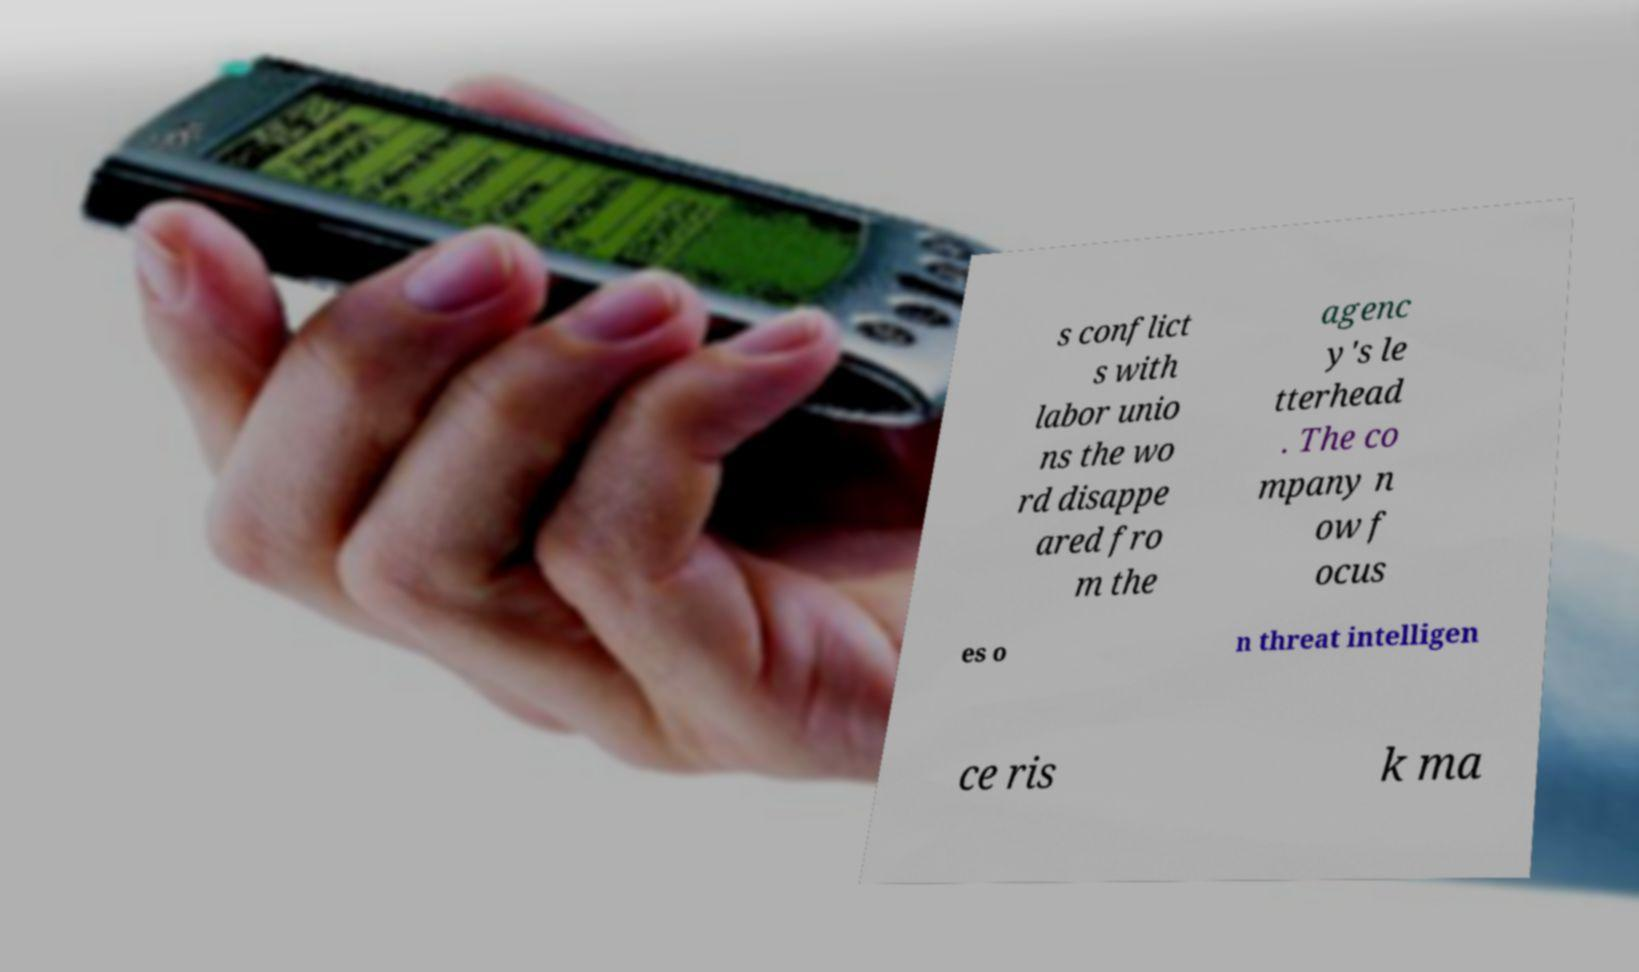For documentation purposes, I need the text within this image transcribed. Could you provide that? s conflict s with labor unio ns the wo rd disappe ared fro m the agenc y's le tterhead . The co mpany n ow f ocus es o n threat intelligen ce ris k ma 